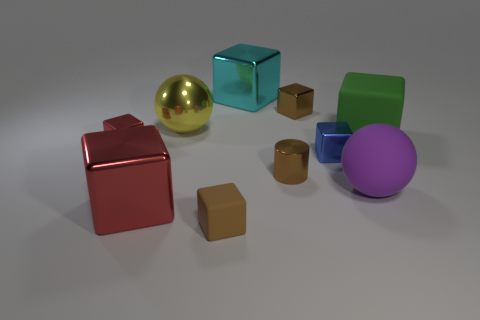Subtract all brown blocks. How many blocks are left? 5 Subtract all red cubes. How many cubes are left? 5 Subtract all cubes. How many objects are left? 3 Subtract all yellow cubes. Subtract all red cylinders. How many cubes are left? 7 Add 5 purple objects. How many purple objects exist? 6 Subtract 1 brown blocks. How many objects are left? 9 Subtract all large yellow things. Subtract all large red blocks. How many objects are left? 8 Add 7 yellow objects. How many yellow objects are left? 8 